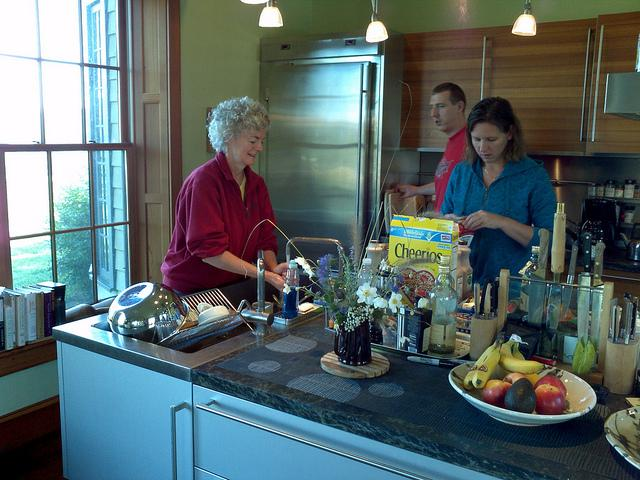What time of day is it? Please explain your reasoning. morning. They have cereal and other breakfast items out 